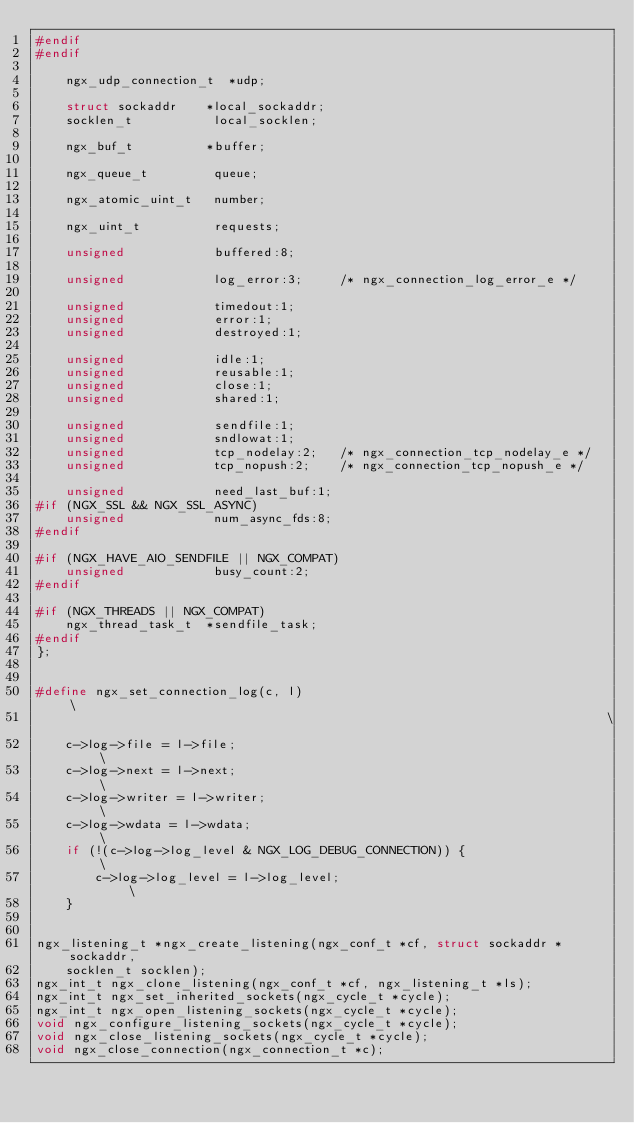Convert code to text. <code><loc_0><loc_0><loc_500><loc_500><_C_>#endif
#endif

    ngx_udp_connection_t  *udp;

    struct sockaddr    *local_sockaddr;
    socklen_t           local_socklen;

    ngx_buf_t          *buffer;

    ngx_queue_t         queue;

    ngx_atomic_uint_t   number;

    ngx_uint_t          requests;

    unsigned            buffered:8;

    unsigned            log_error:3;     /* ngx_connection_log_error_e */

    unsigned            timedout:1;
    unsigned            error:1;
    unsigned            destroyed:1;

    unsigned            idle:1;
    unsigned            reusable:1;
    unsigned            close:1;
    unsigned            shared:1;

    unsigned            sendfile:1;
    unsigned            sndlowat:1;
    unsigned            tcp_nodelay:2;   /* ngx_connection_tcp_nodelay_e */
    unsigned            tcp_nopush:2;    /* ngx_connection_tcp_nopush_e */

    unsigned            need_last_buf:1;
#if (NGX_SSL && NGX_SSL_ASYNC)
    unsigned            num_async_fds:8;
#endif

#if (NGX_HAVE_AIO_SENDFILE || NGX_COMPAT)
    unsigned            busy_count:2;
#endif

#if (NGX_THREADS || NGX_COMPAT)
    ngx_thread_task_t  *sendfile_task;
#endif
};


#define ngx_set_connection_log(c, l)                                         \
                                                                             \
    c->log->file = l->file;                                                  \
    c->log->next = l->next;                                                  \
    c->log->writer = l->writer;                                              \
    c->log->wdata = l->wdata;                                                \
    if (!(c->log->log_level & NGX_LOG_DEBUG_CONNECTION)) {                   \
        c->log->log_level = l->log_level;                                    \
    }


ngx_listening_t *ngx_create_listening(ngx_conf_t *cf, struct sockaddr *sockaddr,
    socklen_t socklen);
ngx_int_t ngx_clone_listening(ngx_conf_t *cf, ngx_listening_t *ls);
ngx_int_t ngx_set_inherited_sockets(ngx_cycle_t *cycle);
ngx_int_t ngx_open_listening_sockets(ngx_cycle_t *cycle);
void ngx_configure_listening_sockets(ngx_cycle_t *cycle);
void ngx_close_listening_sockets(ngx_cycle_t *cycle);
void ngx_close_connection(ngx_connection_t *c);</code> 